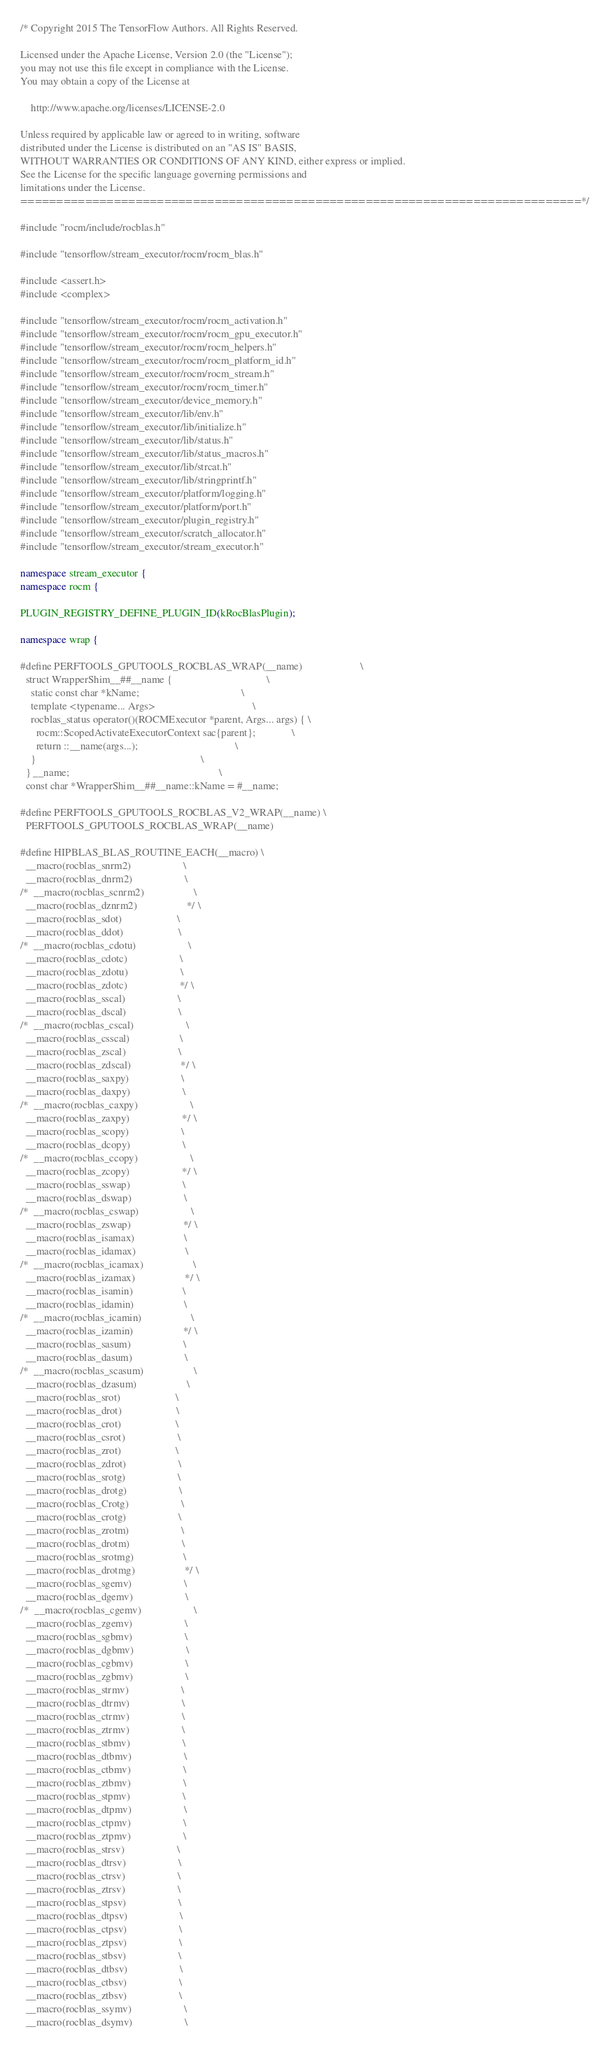<code> <loc_0><loc_0><loc_500><loc_500><_C++_>/* Copyright 2015 The TensorFlow Authors. All Rights Reserved.

Licensed under the Apache License, Version 2.0 (the "License");
you may not use this file except in compliance with the License.
You may obtain a copy of the License at

    http://www.apache.org/licenses/LICENSE-2.0

Unless required by applicable law or agreed to in writing, software
distributed under the License is distributed on an "AS IS" BASIS,
WITHOUT WARRANTIES OR CONDITIONS OF ANY KIND, either express or implied.
See the License for the specific language governing permissions and
limitations under the License.
==============================================================================*/

#include "rocm/include/rocblas.h"

#include "tensorflow/stream_executor/rocm/rocm_blas.h"

#include <assert.h>
#include <complex>

#include "tensorflow/stream_executor/rocm/rocm_activation.h"
#include "tensorflow/stream_executor/rocm/rocm_gpu_executor.h"
#include "tensorflow/stream_executor/rocm/rocm_helpers.h"
#include "tensorflow/stream_executor/rocm/rocm_platform_id.h"
#include "tensorflow/stream_executor/rocm/rocm_stream.h"
#include "tensorflow/stream_executor/rocm/rocm_timer.h"
#include "tensorflow/stream_executor/device_memory.h"
#include "tensorflow/stream_executor/lib/env.h"
#include "tensorflow/stream_executor/lib/initialize.h"
#include "tensorflow/stream_executor/lib/status.h"
#include "tensorflow/stream_executor/lib/status_macros.h"
#include "tensorflow/stream_executor/lib/strcat.h"
#include "tensorflow/stream_executor/lib/stringprintf.h"
#include "tensorflow/stream_executor/platform/logging.h"
#include "tensorflow/stream_executor/platform/port.h"
#include "tensorflow/stream_executor/plugin_registry.h"
#include "tensorflow/stream_executor/scratch_allocator.h"
#include "tensorflow/stream_executor/stream_executor.h"

namespace stream_executor {
namespace rocm {

PLUGIN_REGISTRY_DEFINE_PLUGIN_ID(kRocBlasPlugin);

namespace wrap {

#define PERFTOOLS_GPUTOOLS_ROCBLAS_WRAP(__name)                      \
  struct WrapperShim__##__name {                                    \
    static const char *kName;                                       \
    template <typename... Args>                                     \
    rocblas_status operator()(ROCMExecutor *parent, Args... args) { \
      rocm::ScopedActivateExecutorContext sac{parent};              \
      return ::__name(args...);                                     \
    }                                                               \
  } __name;                                                         \
  const char *WrapperShim__##__name::kName = #__name;

#define PERFTOOLS_GPUTOOLS_ROCBLAS_V2_WRAP(__name) \
  PERFTOOLS_GPUTOOLS_ROCBLAS_WRAP(__name)

#define HIPBLAS_BLAS_ROUTINE_EACH(__macro) \
  __macro(rocblas_snrm2)                    \
  __macro(rocblas_dnrm2)                    \
/*  __macro(rocblas_scnrm2)                   \
  __macro(rocblas_dznrm2)                   */ \
  __macro(rocblas_sdot)                     \
  __macro(rocblas_ddot)                     \
/*  __macro(rocblas_cdotu)                    \
  __macro(rocblas_cdotc)                    \
  __macro(rocblas_zdotu)                    \
  __macro(rocblas_zdotc)                    */ \
  __macro(rocblas_sscal)                    \
  __macro(rocblas_dscal)                    \
/*  __macro(rocblas_cscal)                    \
  __macro(rocblas_csscal)                   \
  __macro(rocblas_zscal)                    \
  __macro(rocblas_zdscal)                   */ \
  __macro(rocblas_saxpy)                    \
  __macro(rocblas_daxpy)                    \
/*  __macro(rocblas_caxpy)                    \
  __macro(rocblas_zaxpy)                    */ \
  __macro(rocblas_scopy)                    \
  __macro(rocblas_dcopy)                    \
/*  __macro(rocblas_ccopy)                    \
  __macro(rocblas_zcopy)                    */ \
  __macro(rocblas_sswap)                    \
  __macro(rocblas_dswap)                    \
/*  __macro(rocblas_cswap)                    \
  __macro(rocblas_zswap)                    */ \
  __macro(rocblas_isamax)                   \
  __macro(rocblas_idamax)                   \
/*  __macro(rocblas_icamax)                   \
  __macro(rocblas_izamax)                   */ \
  __macro(rocblas_isamin)                   \
  __macro(rocblas_idamin)                   \
/*  __macro(rocblas_icamin)                   \
  __macro(rocblas_izamin)                   */ \
  __macro(rocblas_sasum)                    \
  __macro(rocblas_dasum)                    \
/*  __macro(rocblas_scasum)                   \
  __macro(rocblas_dzasum)                   \
  __macro(rocblas_srot)                     \
  __macro(rocblas_drot)                     \
  __macro(rocblas_crot)                     \
  __macro(rocblas_csrot)                    \
  __macro(rocblas_zrot)                     \
  __macro(rocblas_zdrot)                    \
  __macro(rocblas_srotg)                    \
  __macro(rocblas_drotg)                    \
  __macro(rocblas_Crotg)                    \
  __macro(rocblas_crotg)                    \
  __macro(rocblas_zrotm)                    \
  __macro(rocblas_drotm)                    \
  __macro(rocblas_srotmg)                   \
  __macro(rocblas_drotmg)                   */ \
  __macro(rocblas_sgemv)                    \
  __macro(rocblas_dgemv)                    \
/*  __macro(rocblas_cgemv)                    \
  __macro(rocblas_zgemv)                    \
  __macro(rocblas_sgbmv)                    \
  __macro(rocblas_dgbmv)                    \
  __macro(rocblas_cgbmv)                    \
  __macro(rocblas_zgbmv)                    \
  __macro(rocblas_strmv)                    \
  __macro(rocblas_dtrmv)                    \
  __macro(rocblas_ctrmv)                    \
  __macro(rocblas_ztrmv)                    \
  __macro(rocblas_stbmv)                    \
  __macro(rocblas_dtbmv)                    \
  __macro(rocblas_ctbmv)                    \
  __macro(rocblas_ztbmv)                    \
  __macro(rocblas_stpmv)                    \
  __macro(rocblas_dtpmv)                    \
  __macro(rocblas_ctpmv)                    \
  __macro(rocblas_ztpmv)                    \
  __macro(rocblas_strsv)                    \
  __macro(rocblas_dtrsv)                    \
  __macro(rocblas_ctrsv)                    \
  __macro(rocblas_ztrsv)                    \
  __macro(rocblas_stpsv)                    \
  __macro(rocblas_dtpsv)                    \
  __macro(rocblas_ctpsv)                    \
  __macro(rocblas_ztpsv)                    \
  __macro(rocblas_stbsv)                    \
  __macro(rocblas_dtbsv)                    \
  __macro(rocblas_ctbsv)                    \
  __macro(rocblas_ztbsv)                    \
  __macro(rocblas_ssymv)                    \
  __macro(rocblas_dsymv)                    \</code> 